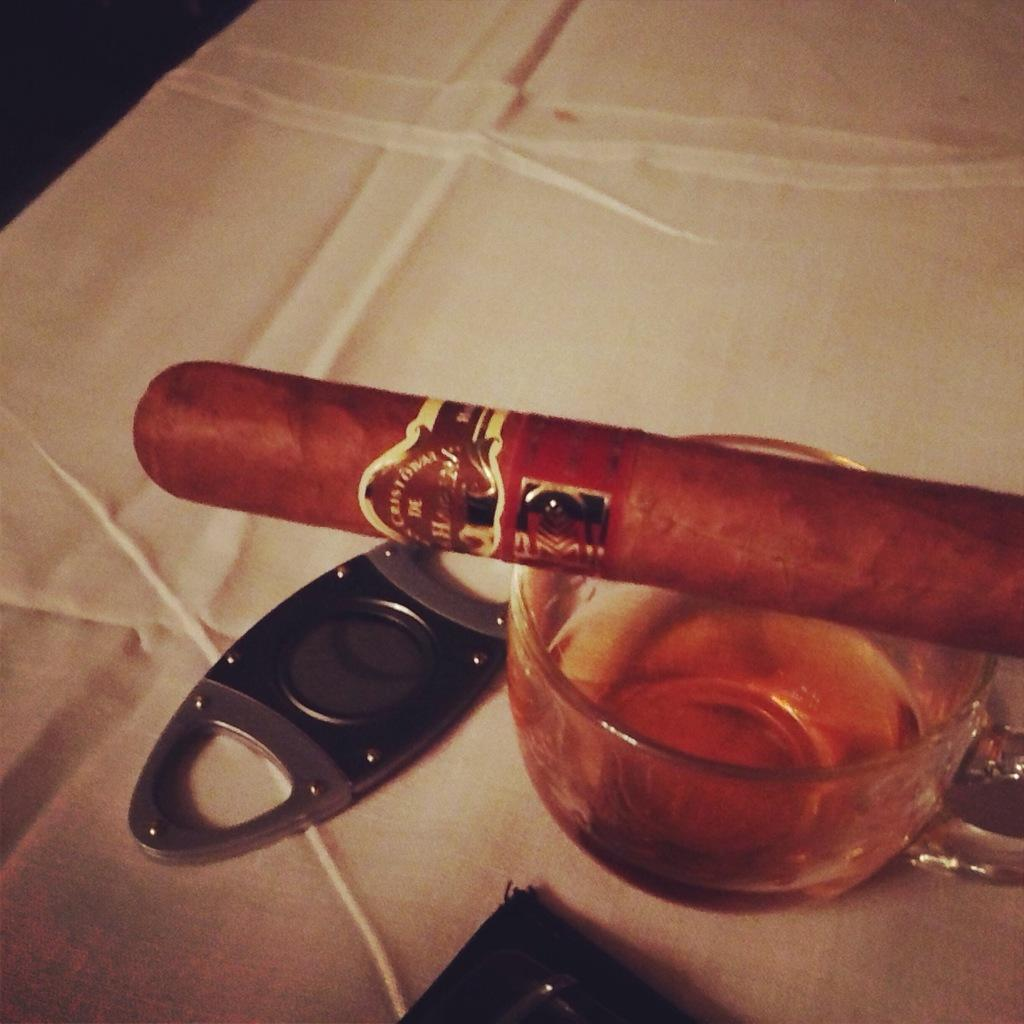What is contained in the cup that is visible in the image? There is a beverage in a cup in the image. What other object can be seen on the table in the image? There is an opener on the table in the image. What is the distance between the cannon and the desk in the image? There is no cannon or desk present in the image. 